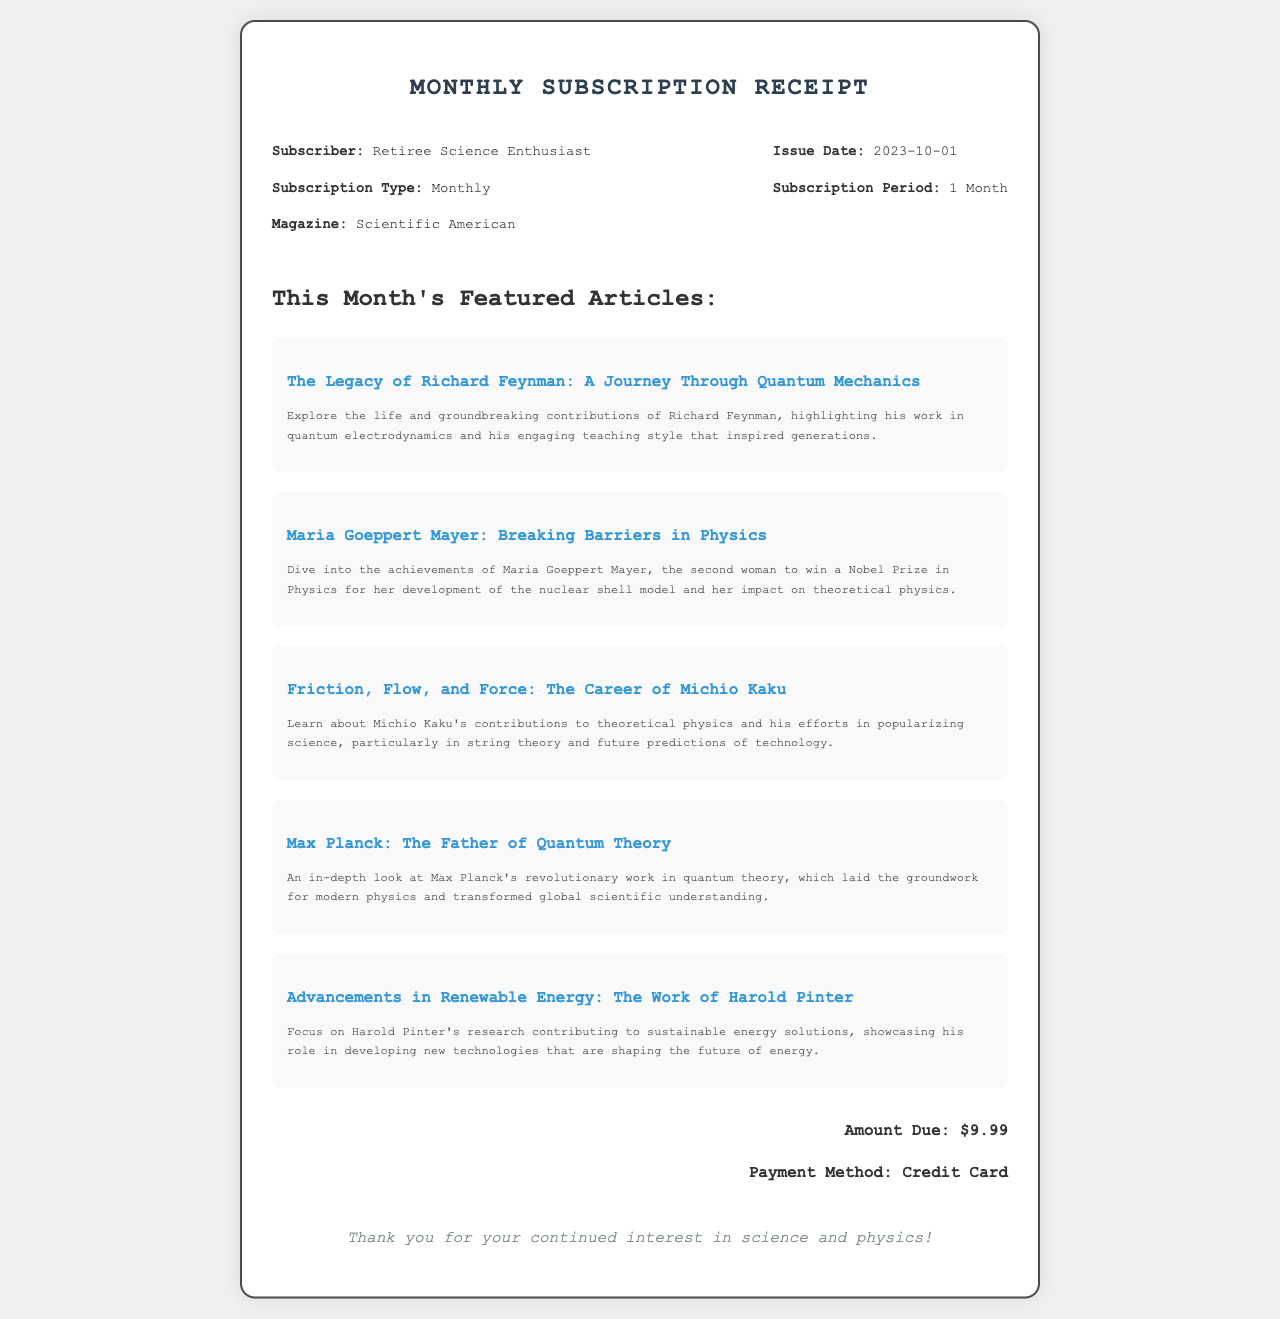What is the name of the subscriber? The subscriber is identified as "Retiree Science Enthusiast" in the document.
Answer: Retiree Science Enthusiast What is the subscription amount? The document states that the amount due for the subscription is $9.99.
Answer: $9.99 Which magazine is being subscribed to? The document specifies that the magazine is "Scientific American."
Answer: Scientific American What is the issue date of the receipt? The issue date provided in the document is "2023-10-01."
Answer: 2023-10-01 Who is featured as the father of quantum theory? The article mentions Max Planck as the father of quantum theory.
Answer: Max Planck How many articles are featured this month? The document lists five featured articles in total.
Answer: 5 What payment method was used for the subscription? The payment method mentioned in the document is "Credit Card."
Answer: Credit Card Which physicist is highlighted for breaking barriers? The document highlights Maria Goeppert Mayer for breaking barriers in physics.
Answer: Maria Goeppert Mayer What is the subscription period for this receipt? The document indicates that the subscription period is "1 Month."
Answer: 1 Month 